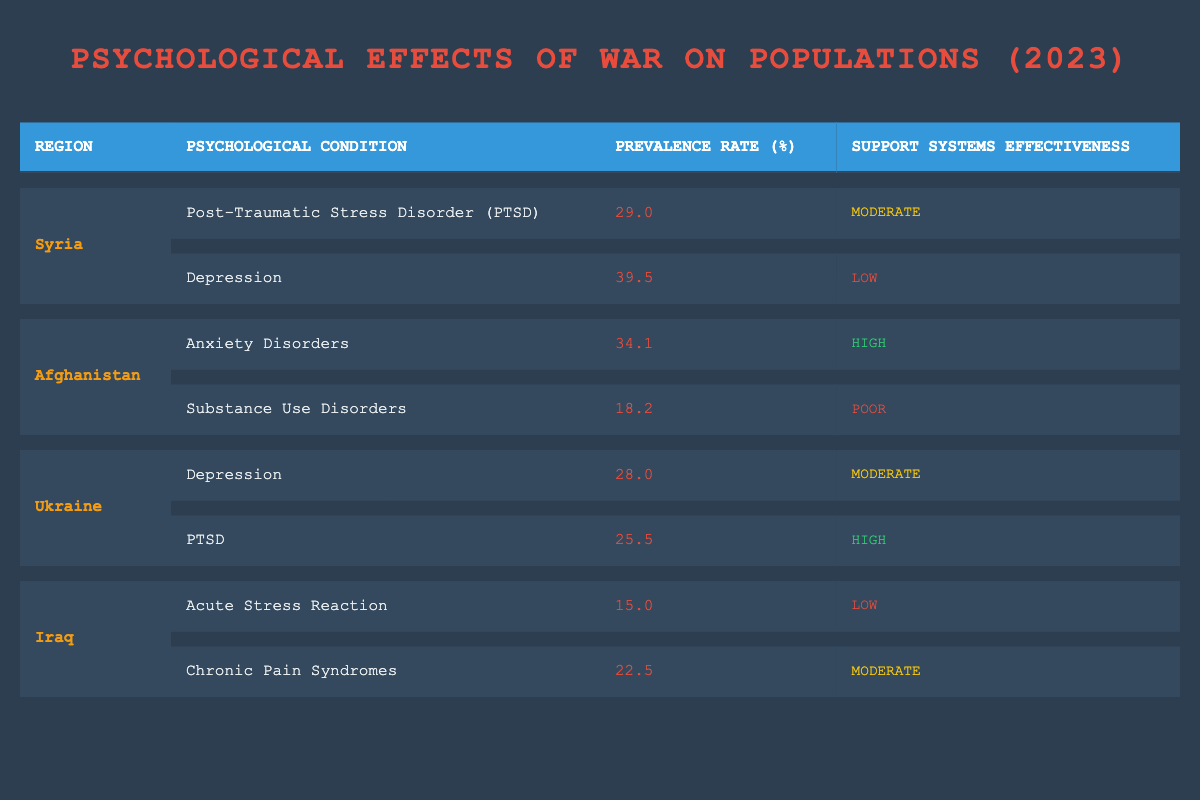What is the prevalence rate of PTSD in Syria? The table shows that the prevalence rate of Post-Traumatic Stress Disorder (PTSD) in Syria is listed in the row corresponding to Syria and the condition PTSD, with a value of 29.0%.
Answer: 29.0 Which psychological condition has the highest prevalence rate in Afghanistan? In the table, looking at Afghanistan's conditions, Anxiety Disorders have a prevalence rate of 34.1%, which is higher than the 18.2% prevalence rate of Substance Use Disorders. Thus, Anxiety Disorders is the highest.
Answer: Anxiety Disorders What is the average prevalence rate of psychological conditions in Iraq? The values for psychological conditions in Iraq are 15.0% (Acute Stress Reaction) and 22.5% (Chronic Pain Syndromes). To calculate the average, we sum these two prevalence rates: 15.0 + 22.5 = 37.5, then divide by 2 to get the average: 37.5 / 2 = 18.75%.
Answer: 18.75 Is the effectiveness of support systems for Depression in Syria low? By checking the table, we see that the effectiveness of support systems for Depression in Syria is noted as "Low." Therefore, the statement is true.
Answer: Yes Considering all regions, which condition has the lowest support system effectiveness? Analyzing support system effectiveness, the lowest categorized is "Poor," which applies to Substance Use Disorders in Afghanistan. This is lower than the "Low" effectiveness seen in other conditions like Depression in Syria and Acute Stress Reaction in Iraq.
Answer: Substance Use Disorders 